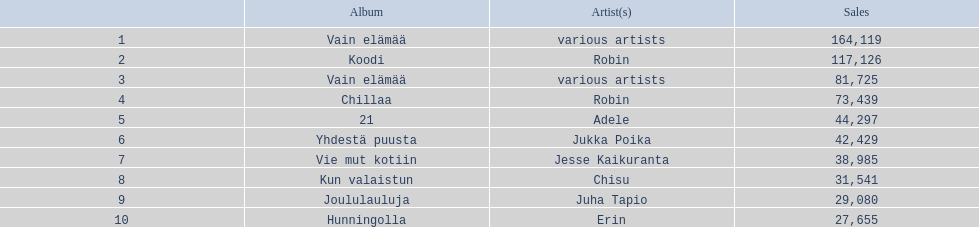Which artists' albums reached number one in finland during 2012? 164,119, 117,126, 81,725, 73,439, 44,297, 42,429, 38,985, 31,541, 29,080, 27,655. What were the sales figures of these albums? Various artists, robin, various artists, robin, adele, jukka poika, jesse kaikuranta, chisu, juha tapio, erin. Give me the full table as a dictionary. {'header': ['', 'Album', 'Artist(s)', 'Sales'], 'rows': [['1', 'Vain elämää', 'various artists', '164,119'], ['2', 'Koodi', 'Robin', '117,126'], ['3', 'Vain elämää', 'various artists', '81,725'], ['4', 'Chillaa', 'Robin', '73,439'], ['5', '21', 'Adele', '44,297'], ['6', 'Yhdestä puusta', 'Jukka Poika', '42,429'], ['7', 'Vie mut kotiin', 'Jesse Kaikuranta', '38,985'], ['8', 'Kun valaistun', 'Chisu', '31,541'], ['9', 'Joululauluja', 'Juha Tapio', '29,080'], ['10', 'Hunningolla', 'Erin', '27,655']]} And did adele or chisu have more sales during this period? Adele. 